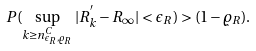<formula> <loc_0><loc_0><loc_500><loc_500>P ( \sup _ { k \geq n ^ { C } _ { \epsilon _ { R } , \varrho _ { R } } } | R ^ { ^ { \prime } } _ { k } - R _ { \infty } | < \epsilon _ { R } ) > ( 1 - \varrho _ { R } ) .</formula> 